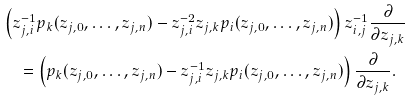Convert formula to latex. <formula><loc_0><loc_0><loc_500><loc_500>& \left ( z _ { j , i } ^ { - 1 } p _ { k } ( z _ { j , 0 } , \dots , z _ { j , n } ) - z _ { j , i } ^ { - 2 } z _ { j , k } p _ { i } ( z _ { j , 0 } , \dots , z _ { j , n } ) \right ) z _ { i , j } ^ { - 1 } \frac { \partial } { \partial z _ { j , k } } \\ & \quad = \left ( p _ { k } ( z _ { j , 0 } , \dots , z _ { j , n } ) - z _ { j , i } ^ { - 1 } z _ { j , k } p _ { i } ( z _ { j , 0 } , \dots , z _ { j , n } ) \right ) \frac { \partial } { \partial z _ { j , k } } .</formula> 